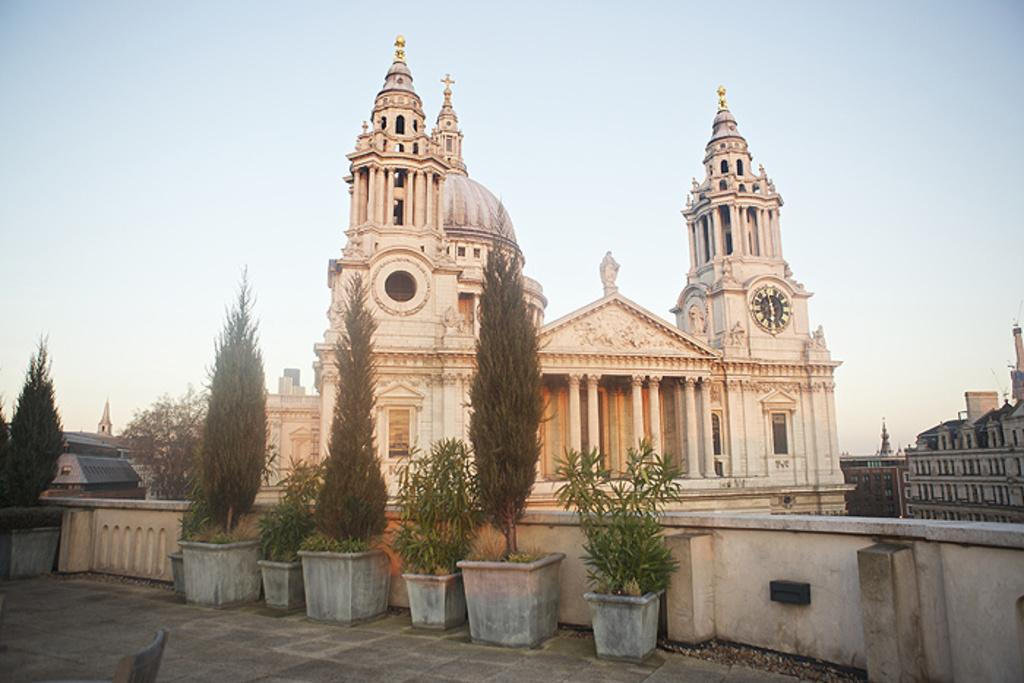What type of plants can be seen in the image? There are house plants in the image. What is located behind the plants? There is a wall in the image. What structures can be seen in the image? There are buildings in the image. What part of the plants is visible in the image? Leaves are present in the image. What additional objects are in the image? There are statues in the image. What can be seen in the distance in the image? The sky is visible in the background of the image. What type of rifle is being used by the person in the image? There is no person or rifle present in the image; it features house plants, a wall, buildings, leaves, statues, and the sky. 